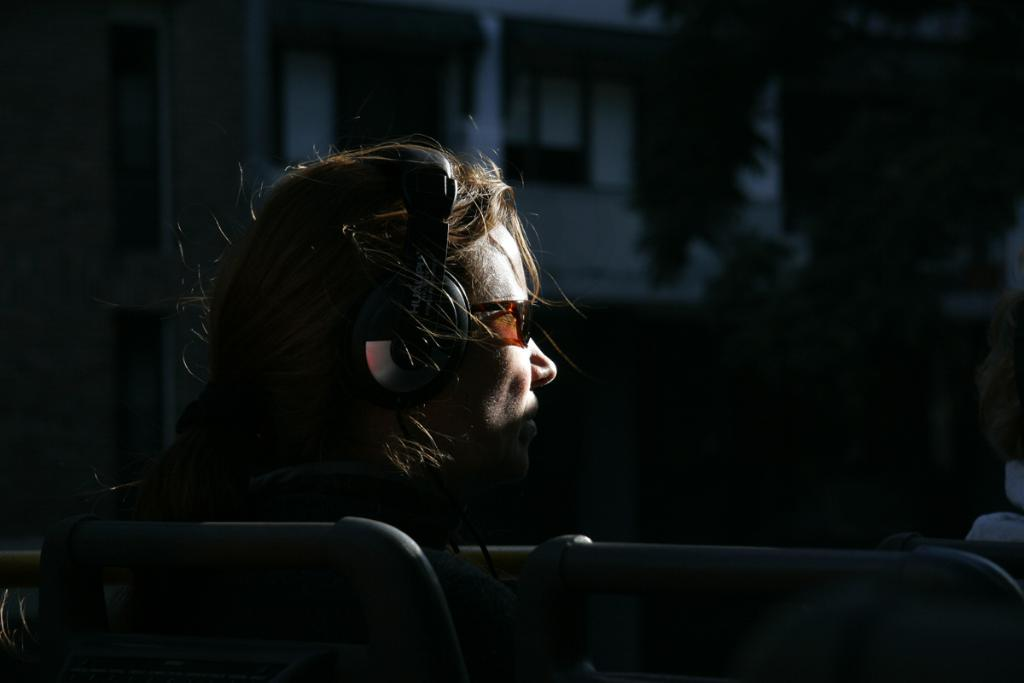What is the person in the image doing? The person is sitting in the image. What can be seen on the person's head? The person is wearing a headphone. What is visible behind the person? There is a tree and a building behind the person. What type of pollution can be seen in the image? There is no pollution visible in the image. Is the image taken during winter? The provided facts do not mention any seasonal details, so it cannot be determined if the image was taken during winter. 